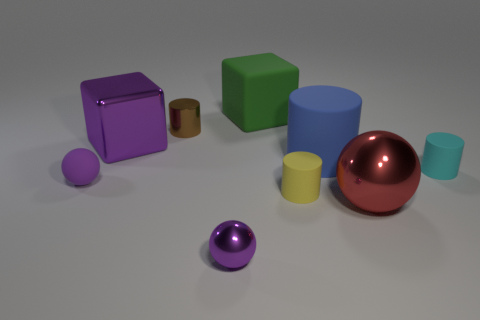Is the material of the small sphere that is behind the yellow rubber cylinder the same as the large object that is left of the large green thing?
Keep it short and to the point. No. The tiny object that is on the left side of the big block that is in front of the tiny cylinder that is behind the small cyan matte cylinder is what shape?
Your response must be concise. Sphere. What number of other big red spheres have the same material as the red sphere?
Keep it short and to the point. 0. How many big cubes are behind the cube on the left side of the metal cylinder?
Provide a succinct answer. 1. Does the tiny rubber cylinder on the left side of the big blue thing have the same color as the block on the right side of the small brown metal cylinder?
Your response must be concise. No. The tiny matte thing that is both to the right of the purple matte sphere and in front of the tiny cyan thing has what shape?
Your answer should be very brief. Cylinder. Is there a purple metallic object of the same shape as the brown metal object?
Make the answer very short. No. What is the shape of the purple thing that is the same size as the red sphere?
Your response must be concise. Cube. What is the material of the brown object?
Keep it short and to the point. Metal. There is a purple ball right of the tiny purple thing behind the big metallic thing that is right of the large purple thing; what is its size?
Offer a very short reply. Small. 